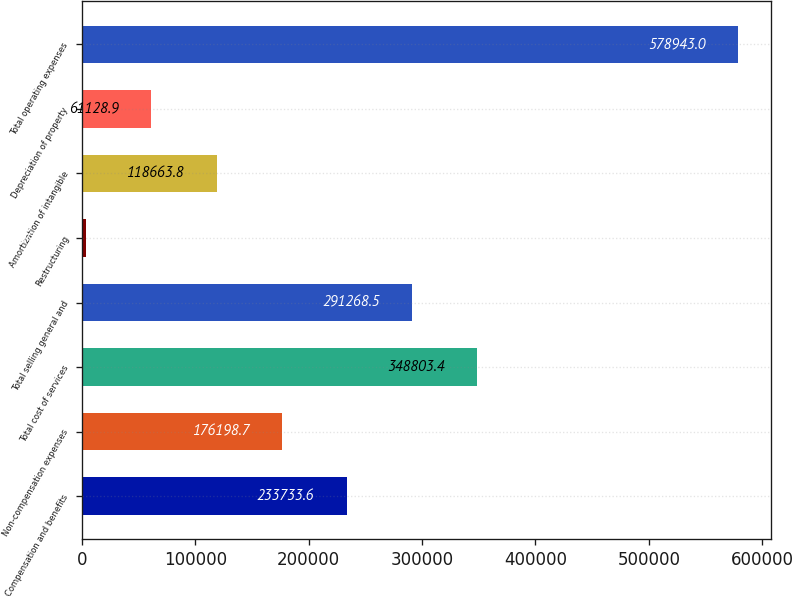Convert chart to OTSL. <chart><loc_0><loc_0><loc_500><loc_500><bar_chart><fcel>Compensation and benefits<fcel>Non-compensation expenses<fcel>Total cost of services<fcel>Total selling general and<fcel>Restructuring<fcel>Amortization of intangible<fcel>Depreciation of property<fcel>Total operating expenses<nl><fcel>233734<fcel>176199<fcel>348803<fcel>291268<fcel>3594<fcel>118664<fcel>61128.9<fcel>578943<nl></chart> 